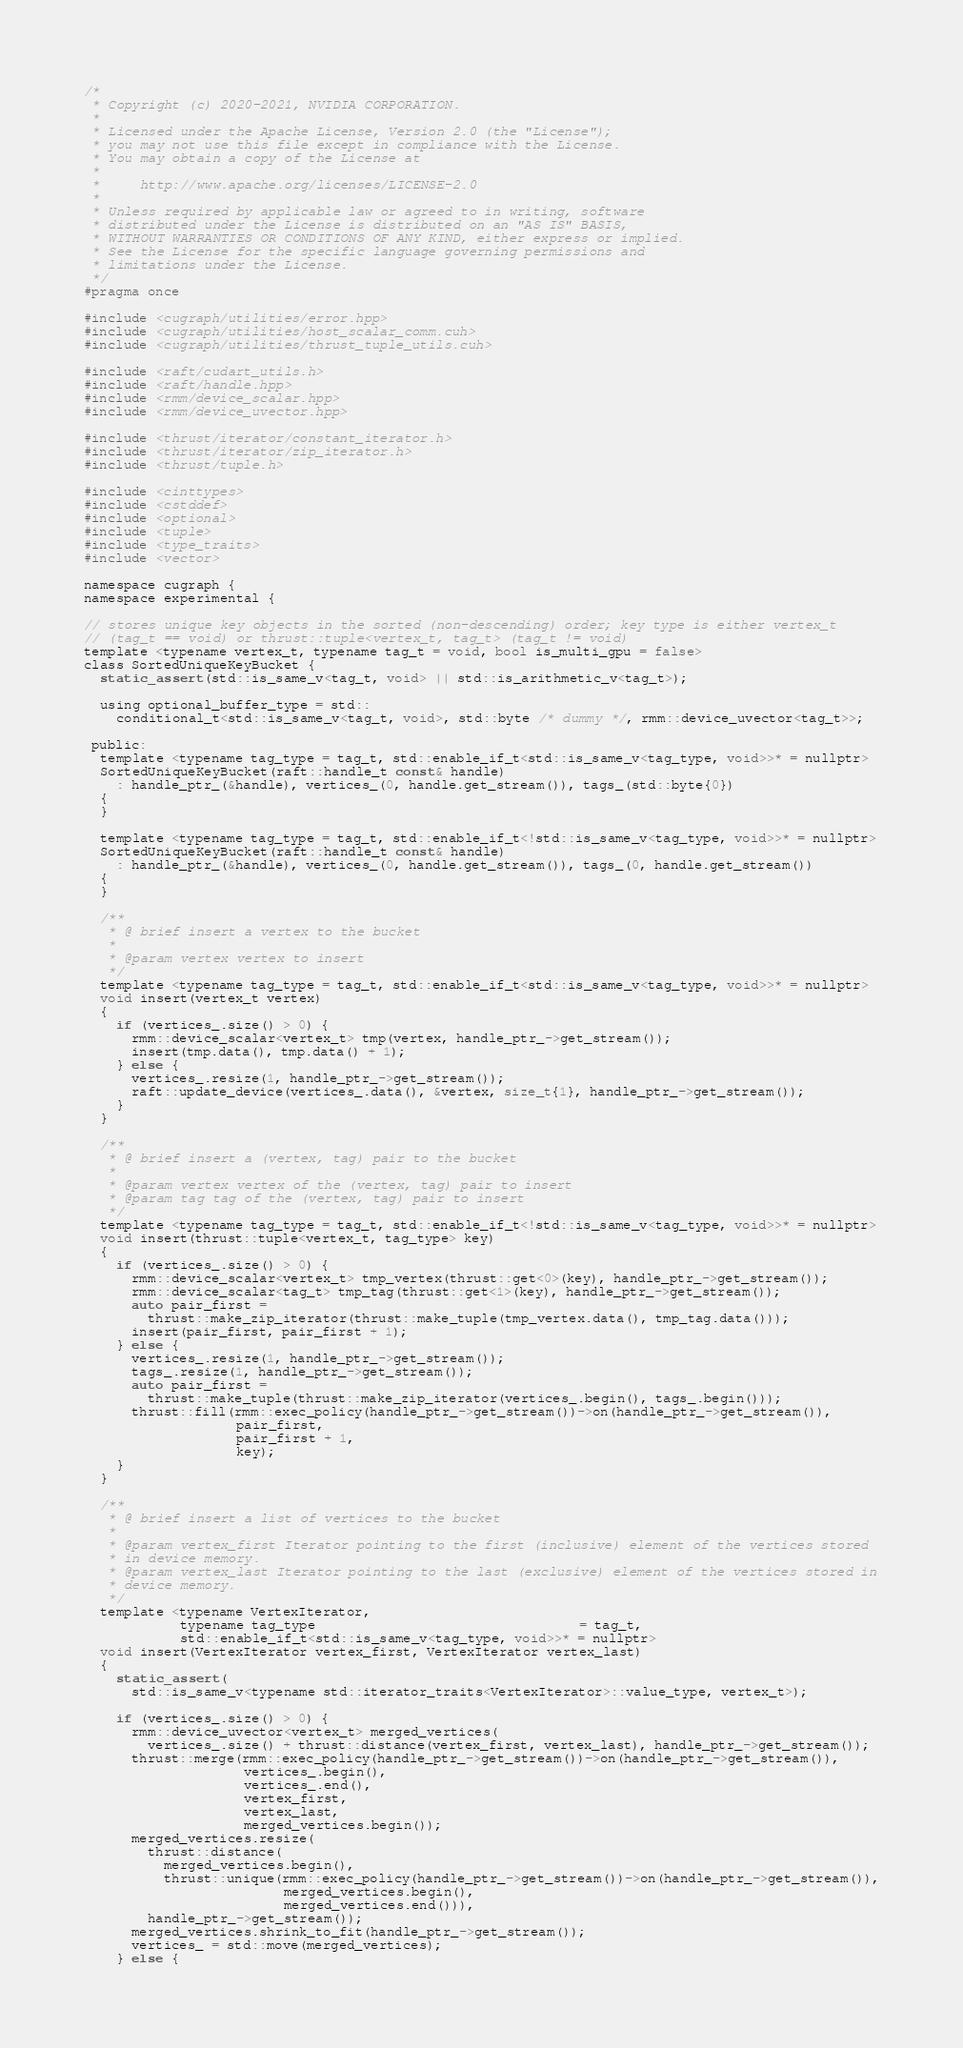<code> <loc_0><loc_0><loc_500><loc_500><_Cuda_>/*
 * Copyright (c) 2020-2021, NVIDIA CORPORATION.
 *
 * Licensed under the Apache License, Version 2.0 (the "License");
 * you may not use this file except in compliance with the License.
 * You may obtain a copy of the License at
 *
 *     http://www.apache.org/licenses/LICENSE-2.0
 *
 * Unless required by applicable law or agreed to in writing, software
 * distributed under the License is distributed on an "AS IS" BASIS,
 * WITHOUT WARRANTIES OR CONDITIONS OF ANY KIND, either express or implied.
 * See the License for the specific language governing permissions and
 * limitations under the License.
 */
#pragma once

#include <cugraph/utilities/error.hpp>
#include <cugraph/utilities/host_scalar_comm.cuh>
#include <cugraph/utilities/thrust_tuple_utils.cuh>

#include <raft/cudart_utils.h>
#include <raft/handle.hpp>
#include <rmm/device_scalar.hpp>
#include <rmm/device_uvector.hpp>

#include <thrust/iterator/constant_iterator.h>
#include <thrust/iterator/zip_iterator.h>
#include <thrust/tuple.h>

#include <cinttypes>
#include <cstddef>
#include <optional>
#include <tuple>
#include <type_traits>
#include <vector>

namespace cugraph {
namespace experimental {

// stores unique key objects in the sorted (non-descending) order; key type is either vertex_t
// (tag_t == void) or thrust::tuple<vertex_t, tag_t> (tag_t != void)
template <typename vertex_t, typename tag_t = void, bool is_multi_gpu = false>
class SortedUniqueKeyBucket {
  static_assert(std::is_same_v<tag_t, void> || std::is_arithmetic_v<tag_t>);

  using optional_buffer_type = std::
    conditional_t<std::is_same_v<tag_t, void>, std::byte /* dummy */, rmm::device_uvector<tag_t>>;

 public:
  template <typename tag_type = tag_t, std::enable_if_t<std::is_same_v<tag_type, void>>* = nullptr>
  SortedUniqueKeyBucket(raft::handle_t const& handle)
    : handle_ptr_(&handle), vertices_(0, handle.get_stream()), tags_(std::byte{0})
  {
  }

  template <typename tag_type = tag_t, std::enable_if_t<!std::is_same_v<tag_type, void>>* = nullptr>
  SortedUniqueKeyBucket(raft::handle_t const& handle)
    : handle_ptr_(&handle), vertices_(0, handle.get_stream()), tags_(0, handle.get_stream())
  {
  }

  /**
   * @ brief insert a vertex to the bucket
   *
   * @param vertex vertex to insert
   */
  template <typename tag_type = tag_t, std::enable_if_t<std::is_same_v<tag_type, void>>* = nullptr>
  void insert(vertex_t vertex)
  {
    if (vertices_.size() > 0) {
      rmm::device_scalar<vertex_t> tmp(vertex, handle_ptr_->get_stream());
      insert(tmp.data(), tmp.data() + 1);
    } else {
      vertices_.resize(1, handle_ptr_->get_stream());
      raft::update_device(vertices_.data(), &vertex, size_t{1}, handle_ptr_->get_stream());
    }
  }

  /**
   * @ brief insert a (vertex, tag) pair to the bucket
   *
   * @param vertex vertex of the (vertex, tag) pair to insert
   * @param tag tag of the (vertex, tag) pair to insert
   */
  template <typename tag_type = tag_t, std::enable_if_t<!std::is_same_v<tag_type, void>>* = nullptr>
  void insert(thrust::tuple<vertex_t, tag_type> key)
  {
    if (vertices_.size() > 0) {
      rmm::device_scalar<vertex_t> tmp_vertex(thrust::get<0>(key), handle_ptr_->get_stream());
      rmm::device_scalar<tag_t> tmp_tag(thrust::get<1>(key), handle_ptr_->get_stream());
      auto pair_first =
        thrust::make_zip_iterator(thrust::make_tuple(tmp_vertex.data(), tmp_tag.data()));
      insert(pair_first, pair_first + 1);
    } else {
      vertices_.resize(1, handle_ptr_->get_stream());
      tags_.resize(1, handle_ptr_->get_stream());
      auto pair_first =
        thrust::make_tuple(thrust::make_zip_iterator(vertices_.begin(), tags_.begin()));
      thrust::fill(rmm::exec_policy(handle_ptr_->get_stream())->on(handle_ptr_->get_stream()),
                   pair_first,
                   pair_first + 1,
                   key);
    }
  }

  /**
   * @ brief insert a list of vertices to the bucket
   *
   * @param vertex_first Iterator pointing to the first (inclusive) element of the vertices stored
   * in device memory.
   * @param vertex_last Iterator pointing to the last (exclusive) element of the vertices stored in
   * device memory.
   */
  template <typename VertexIterator,
            typename tag_type                                 = tag_t,
            std::enable_if_t<std::is_same_v<tag_type, void>>* = nullptr>
  void insert(VertexIterator vertex_first, VertexIterator vertex_last)
  {
    static_assert(
      std::is_same_v<typename std::iterator_traits<VertexIterator>::value_type, vertex_t>);

    if (vertices_.size() > 0) {
      rmm::device_uvector<vertex_t> merged_vertices(
        vertices_.size() + thrust::distance(vertex_first, vertex_last), handle_ptr_->get_stream());
      thrust::merge(rmm::exec_policy(handle_ptr_->get_stream())->on(handle_ptr_->get_stream()),
                    vertices_.begin(),
                    vertices_.end(),
                    vertex_first,
                    vertex_last,
                    merged_vertices.begin());
      merged_vertices.resize(
        thrust::distance(
          merged_vertices.begin(),
          thrust::unique(rmm::exec_policy(handle_ptr_->get_stream())->on(handle_ptr_->get_stream()),
                         merged_vertices.begin(),
                         merged_vertices.end())),
        handle_ptr_->get_stream());
      merged_vertices.shrink_to_fit(handle_ptr_->get_stream());
      vertices_ = std::move(merged_vertices);
    } else {</code> 